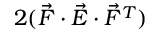<formula> <loc_0><loc_0><loc_500><loc_500>2 ( \vec { F } \cdot \vec { E } \cdot \vec { F } ^ { T } )</formula> 